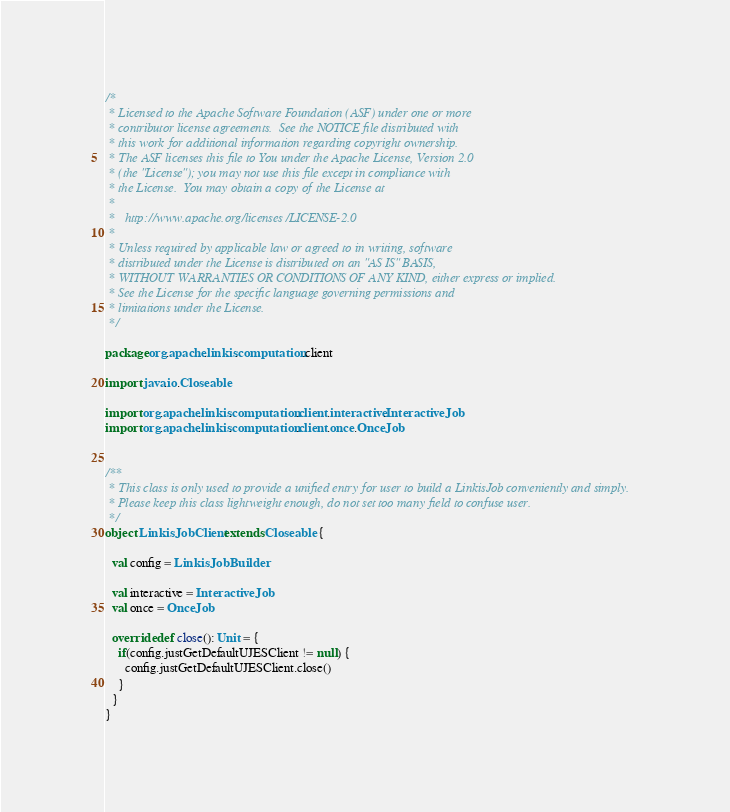<code> <loc_0><loc_0><loc_500><loc_500><_Scala_>/*
 * Licensed to the Apache Software Foundation (ASF) under one or more
 * contributor license agreements.  See the NOTICE file distributed with
 * this work for additional information regarding copyright ownership.
 * The ASF licenses this file to You under the Apache License, Version 2.0
 * (the "License"); you may not use this file except in compliance with
 * the License.  You may obtain a copy of the License at
 * 
 *   http://www.apache.org/licenses/LICENSE-2.0
 * 
 * Unless required by applicable law or agreed to in writing, software
 * distributed under the License is distributed on an "AS IS" BASIS,
 * WITHOUT WARRANTIES OR CONDITIONS OF ANY KIND, either express or implied.
 * See the License for the specific language governing permissions and
 * limitations under the License.
 */
 
package org.apache.linkis.computation.client

import java.io.Closeable

import org.apache.linkis.computation.client.interactive.InteractiveJob
import org.apache.linkis.computation.client.once.OnceJob


/**
 * This class is only used to provide a unified entry for user to build a LinkisJob conveniently and simply.
 * Please keep this class lightweight enough, do not set too many field to confuse user.
 */
object LinkisJobClient extends Closeable {

  val config = LinkisJobBuilder

  val interactive = InteractiveJob
  val once = OnceJob

  override def close(): Unit = {
    if(config.justGetDefaultUJESClient != null) {
      config.justGetDefaultUJESClient.close()
    }
  }
}
</code> 